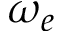<formula> <loc_0><loc_0><loc_500><loc_500>\omega _ { e }</formula> 